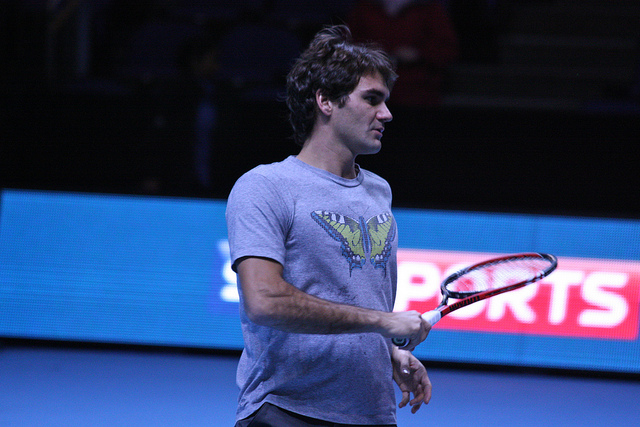<image>Who is the sponsor of this event? The sponsor of this event is unknown. It could potentially be 'e sports', 'dicks sporting goods', or 'ea sports'. Who is the sponsor of this event? I am not sure who is the sponsor of this event. It can be either sports or e sports. 